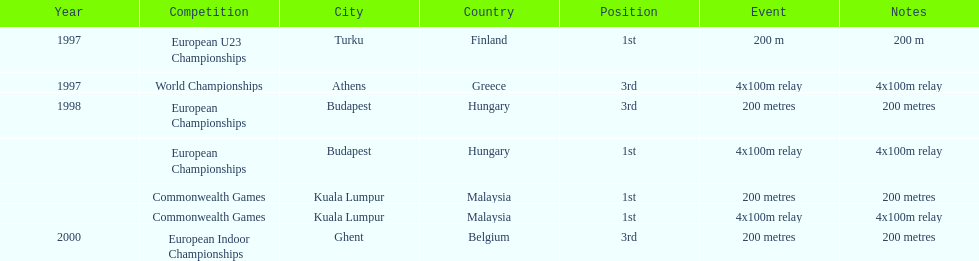How many times was golding in 2nd position? 0. 